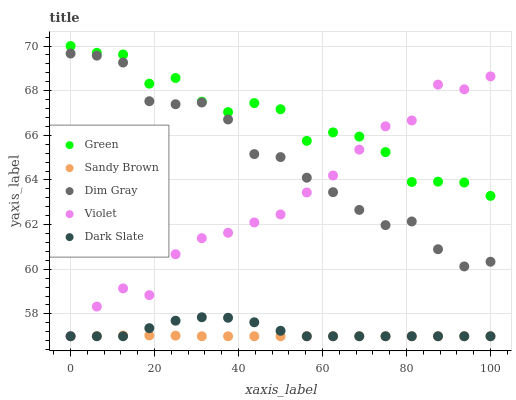Does Sandy Brown have the minimum area under the curve?
Answer yes or no. Yes. Does Green have the maximum area under the curve?
Answer yes or no. Yes. Does Dim Gray have the minimum area under the curve?
Answer yes or no. No. Does Dim Gray have the maximum area under the curve?
Answer yes or no. No. Is Sandy Brown the smoothest?
Answer yes or no. Yes. Is Green the roughest?
Answer yes or no. Yes. Is Dim Gray the smoothest?
Answer yes or no. No. Is Dim Gray the roughest?
Answer yes or no. No. Does Sandy Brown have the lowest value?
Answer yes or no. Yes. Does Dim Gray have the lowest value?
Answer yes or no. No. Does Green have the highest value?
Answer yes or no. Yes. Does Dim Gray have the highest value?
Answer yes or no. No. Is Dark Slate less than Dim Gray?
Answer yes or no. Yes. Is Green greater than Sandy Brown?
Answer yes or no. Yes. Does Violet intersect Green?
Answer yes or no. Yes. Is Violet less than Green?
Answer yes or no. No. Is Violet greater than Green?
Answer yes or no. No. Does Dark Slate intersect Dim Gray?
Answer yes or no. No. 